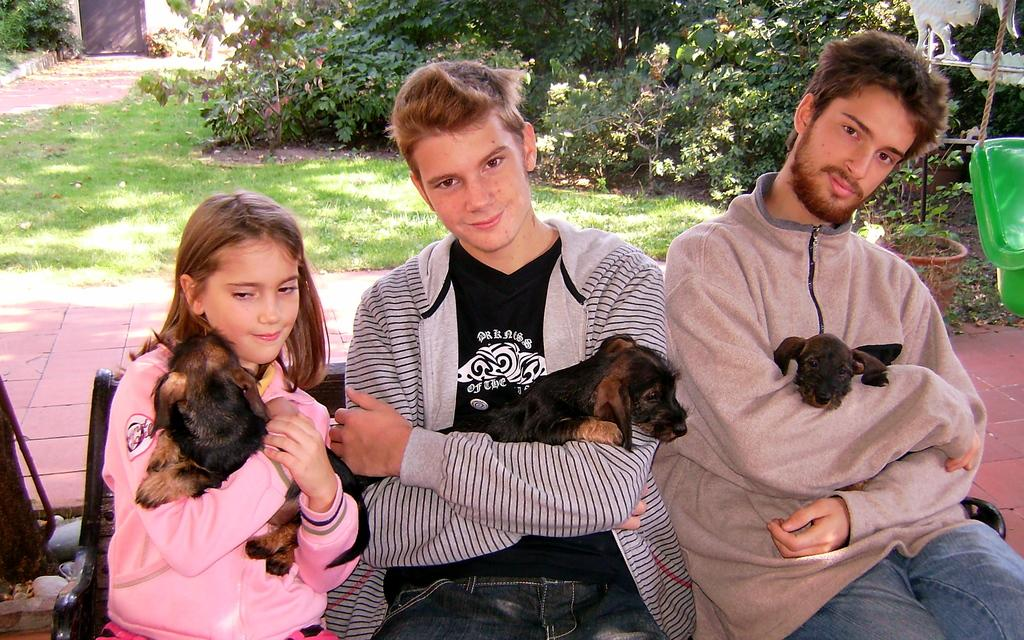How many people are in the image? There are three people in the image. What are the people doing in the image? The people are sitting and holding dogs. What can be seen in the background of the image? There are trees, bins, and grass in the background of the image. Can you see any cobwebs in the image? There are no cobwebs present in the image. What type of grape is being eaten by the stranger in the image? There is no stranger or grape present in the image. 